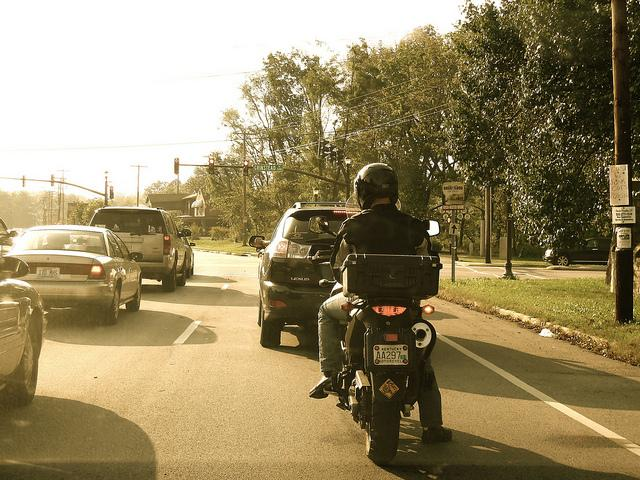For What reason does the person on the motorcycle have their right leg on the street? Please explain your reasoning. balance. They are stopped and have their leg down so the bike stays up. 